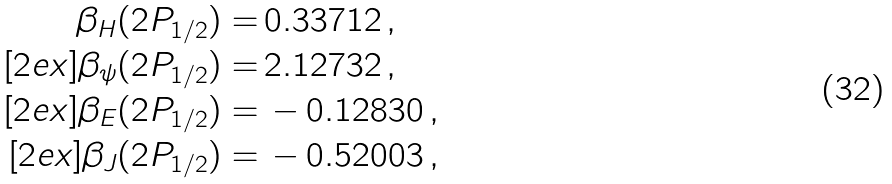<formula> <loc_0><loc_0><loc_500><loc_500>\beta _ { H } ( 2 P _ { 1 / 2 } ) = & \, 0 . 3 3 7 1 2 \, , \\ [ 2 e x ] \beta _ { \psi } ( 2 P _ { 1 / 2 } ) = & \, 2 . 1 2 7 3 2 \, , \\ [ 2 e x ] \beta _ { E } ( 2 P _ { 1 / 2 } ) = & \, - 0 . 1 2 8 3 0 \, , \\ [ 2 e x ] \beta _ { J } ( 2 P _ { 1 / 2 } ) = & \, - 0 . 5 2 0 0 3 \, ,</formula> 